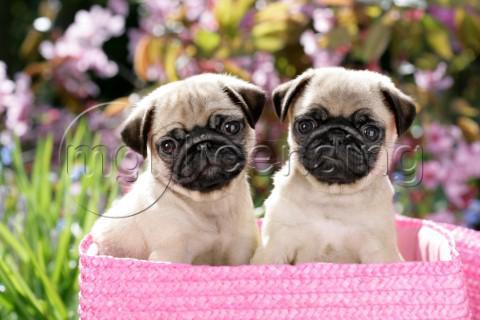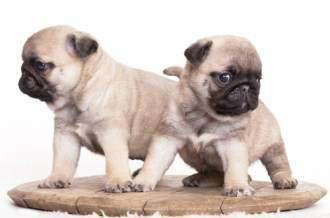The first image is the image on the left, the second image is the image on the right. Given the left and right images, does the statement "Two nearly identical looking pug puppies lie flat on their bellies, side-by-side, with eyes closed." hold true? Answer yes or no. No. The first image is the image on the left, the second image is the image on the right. For the images displayed, is the sentence "One pair of dogs is sitting in front of some flowers." factually correct? Answer yes or no. Yes. 